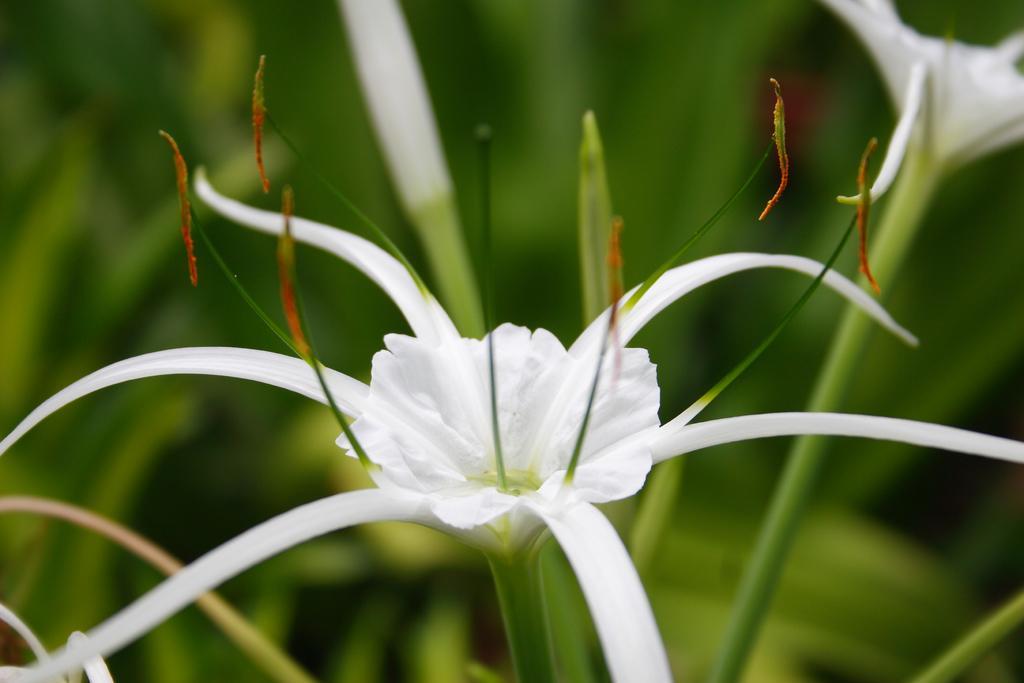Please provide a concise description of this image. In this image, we can see white flowers with stems. Background there is a blur view. Here we can see green color. 